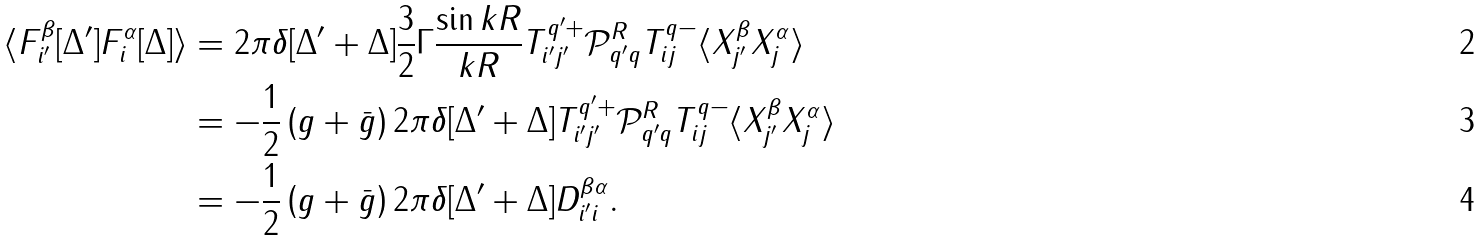<formula> <loc_0><loc_0><loc_500><loc_500>\langle F _ { i ^ { \prime } } ^ { \beta } [ \Delta ^ { \prime } ] F _ { i } ^ { \alpha } [ \Delta ] \rangle & = 2 \pi \delta [ \Delta ^ { \prime } + \Delta ] \frac { 3 } { 2 } \Gamma \frac { \sin { k R } } { k R } T _ { i ^ { \prime } j ^ { \prime } } ^ { q ^ { \prime } + } \mathcal { P } ^ { R } _ { q ^ { \prime } q } T _ { i j } ^ { q - } \langle X _ { j ^ { \prime } } ^ { \beta } X _ { j } ^ { \alpha } \rangle \\ & = - \frac { 1 } { 2 } \left ( g + \bar { g } \right ) 2 \pi \delta [ \Delta ^ { \prime } + \Delta ] T _ { i ^ { \prime } j ^ { \prime } } ^ { q ^ { \prime } + } \mathcal { P } ^ { R } _ { q ^ { \prime } q } T _ { i j } ^ { q - } \langle X _ { j ^ { \prime } } ^ { \beta } X _ { j } ^ { \alpha } \rangle \\ & = - \frac { 1 } { 2 } \left ( g + \bar { g } \right ) 2 \pi \delta [ \Delta ^ { \prime } + \Delta ] D ^ { \beta \alpha } _ { i ^ { \prime } i } .</formula> 